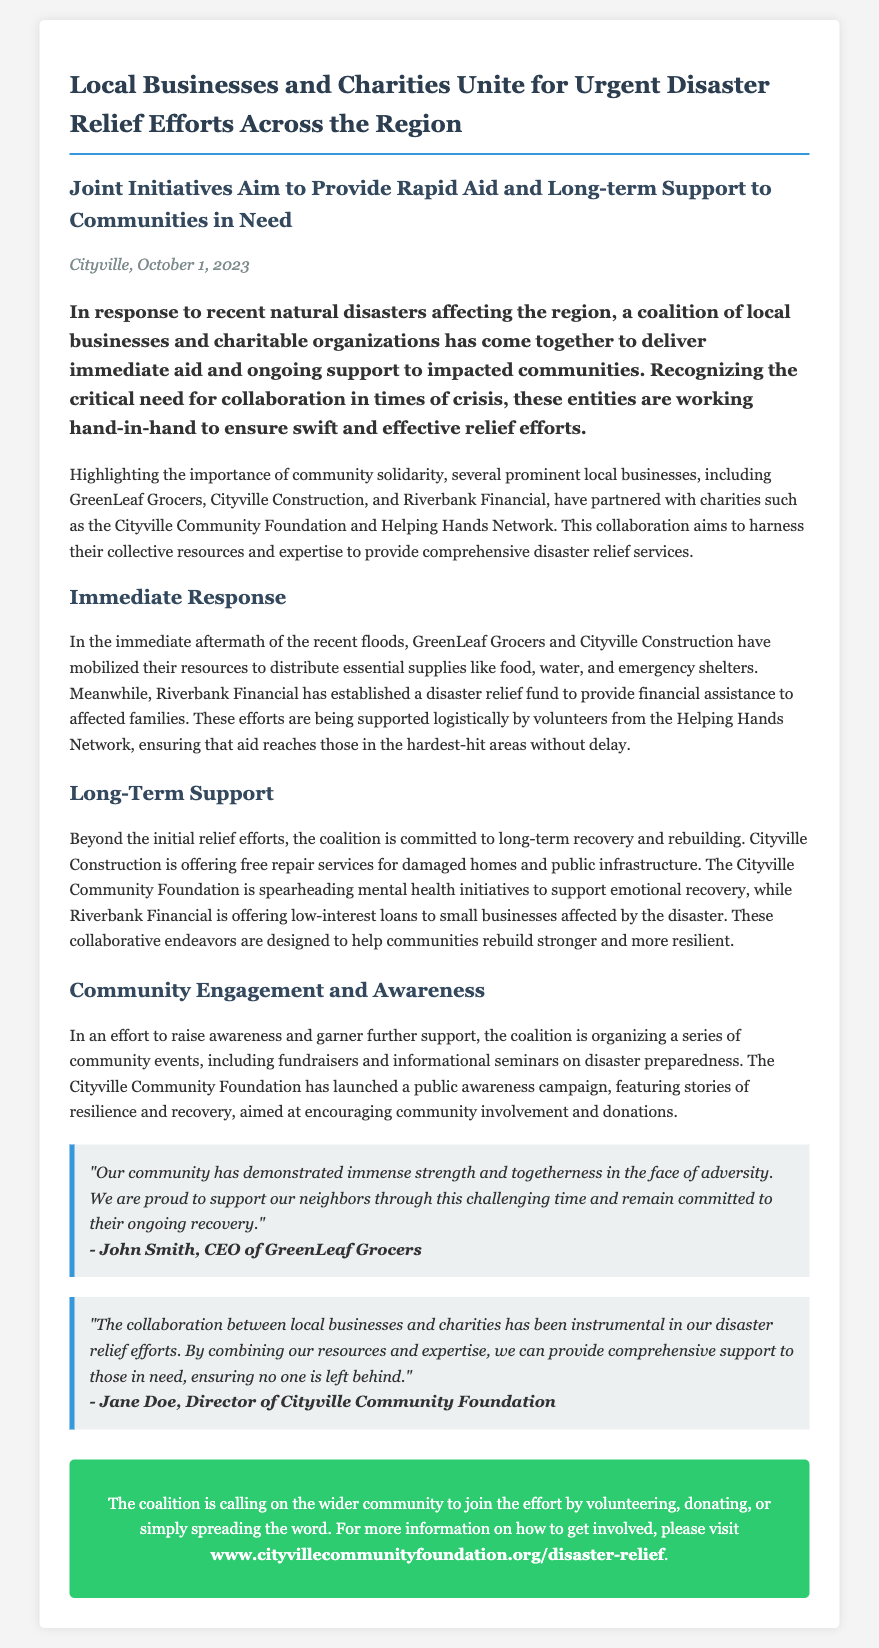What is the date of the press release? The date of the press release is found in the dateline section, which is October 1, 2023.
Answer: October 1, 2023 What type of businesses are involved in the coalition? The press release mentions specific types of businesses: GreenLeaf Grocers, Cityville Construction, and Riverbank Financial.
Answer: local businesses Which charity is mentioned as a partner? The document lists specific charities; one of them is the Cityville Community Foundation.
Answer: Cityville Community Foundation What essential supplies are distributed by GreenLeaf Grocers and Cityville Construction? The document states that these businesses distributed food, water, and emergency shelters.
Answer: food, water, and emergency shelters How is Riverbank Financial contributing to the disaster relief efforts? Riverbank Financial has established a disaster relief fund for financial assistance, as mentioned in the immediate response section.
Answer: disaster relief fund What is the focus of the long-term support mentioned in the document? The document indicates that long-term support includes repair services, mental health initiatives, and low-interest loans to small businesses.
Answer: recovery and rebuilding Who is quoted regarding the strength of the community? The quote about community strength comes from John Smith, the CEO of GreenLeaf Grocers.
Answer: John Smith What type of events is the coalition organizing for community engagement? The coalition is organizing community events such as fundraisers and informational seminars, as noted in the community engagement section.
Answer: fundraisers and informational seminars 